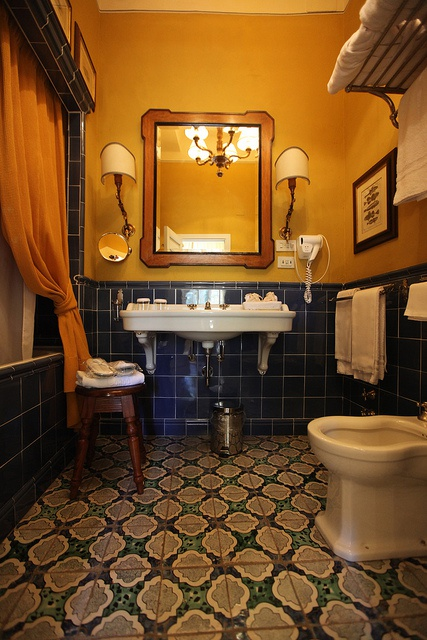Describe the objects in this image and their specific colors. I can see toilet in black, maroon, olive, and gray tones, sink in black, darkgray, and tan tones, hair drier in black and tan tones, and bottle in black, tan, and lightgray tones in this image. 